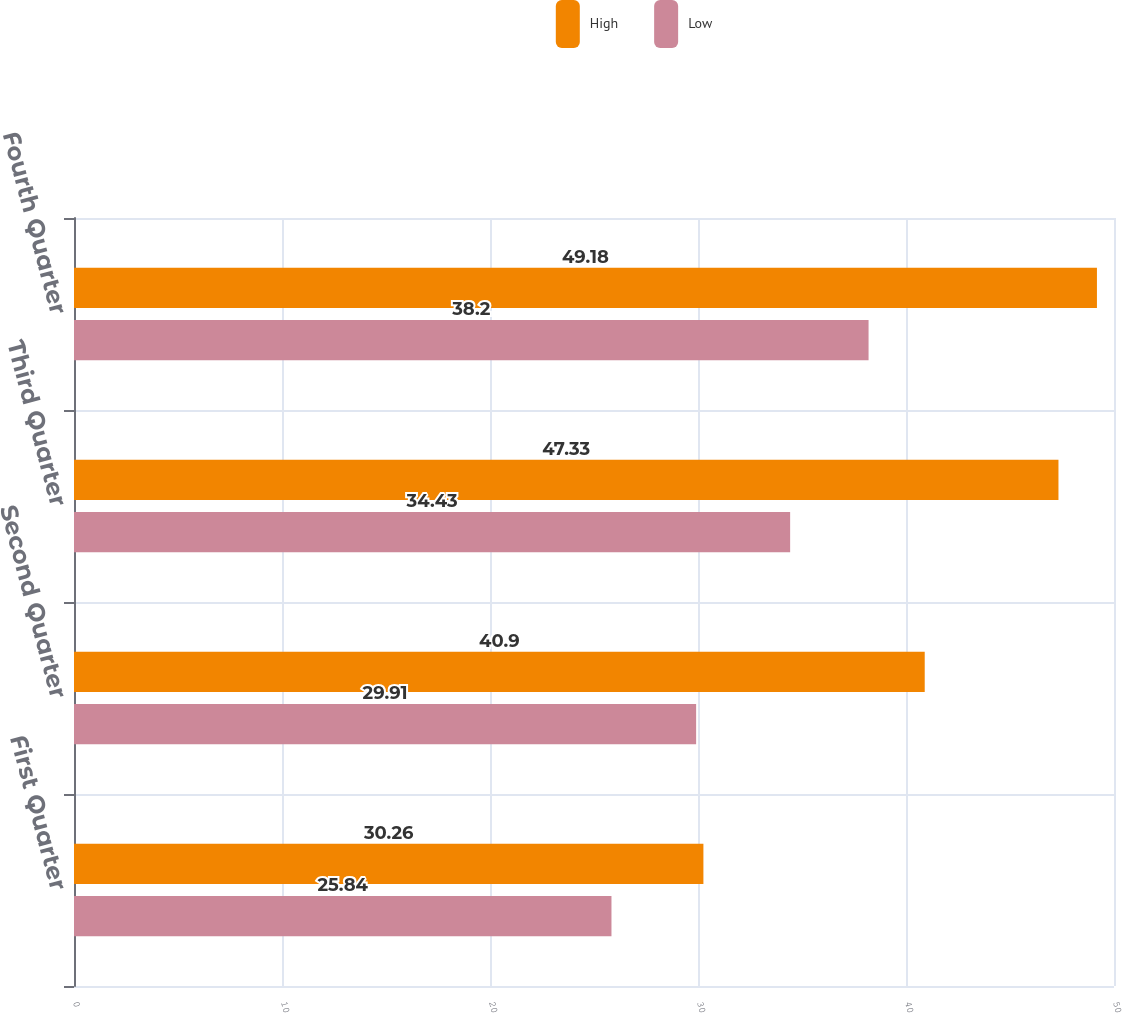Convert chart. <chart><loc_0><loc_0><loc_500><loc_500><stacked_bar_chart><ecel><fcel>First Quarter<fcel>Second Quarter<fcel>Third Quarter<fcel>Fourth Quarter<nl><fcel>High<fcel>30.26<fcel>40.9<fcel>47.33<fcel>49.18<nl><fcel>Low<fcel>25.84<fcel>29.91<fcel>34.43<fcel>38.2<nl></chart> 